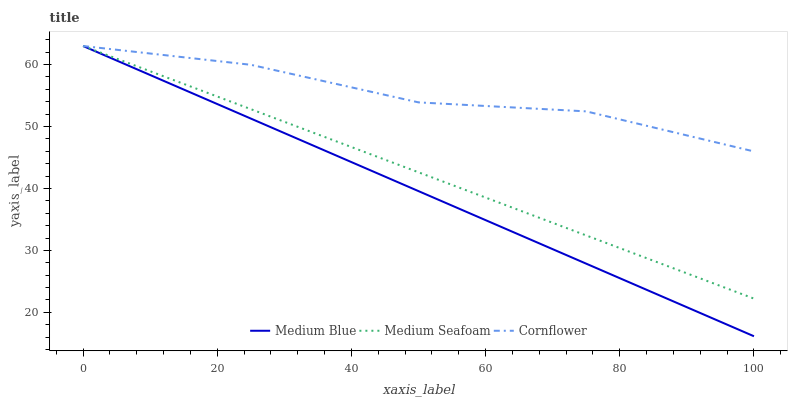Does Medium Blue have the minimum area under the curve?
Answer yes or no. Yes. Does Cornflower have the maximum area under the curve?
Answer yes or no. Yes. Does Medium Seafoam have the minimum area under the curve?
Answer yes or no. No. Does Medium Seafoam have the maximum area under the curve?
Answer yes or no. No. Is Medium Blue the smoothest?
Answer yes or no. Yes. Is Cornflower the roughest?
Answer yes or no. Yes. Is Medium Seafoam the roughest?
Answer yes or no. No. Does Medium Seafoam have the lowest value?
Answer yes or no. No. 